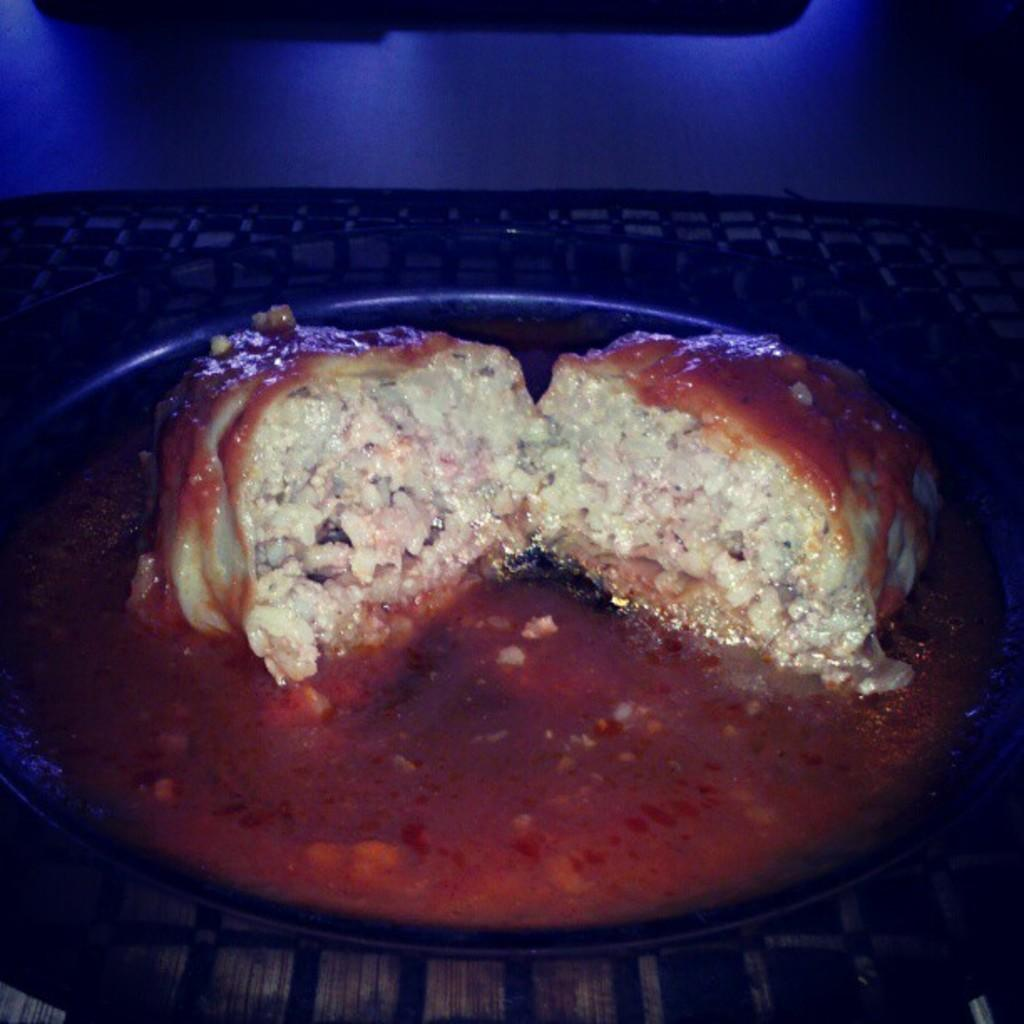What is the main subject of the image? There is a food item in the image. How is the food item presented in the image? The food item is on a plate. What type of lead can be seen in the image? There is no lead present in the image; it features a food item on a plate. What type of spoon is used to serve the food in the image? There is no spoon visible in the image; only the food item and the plate are present. 